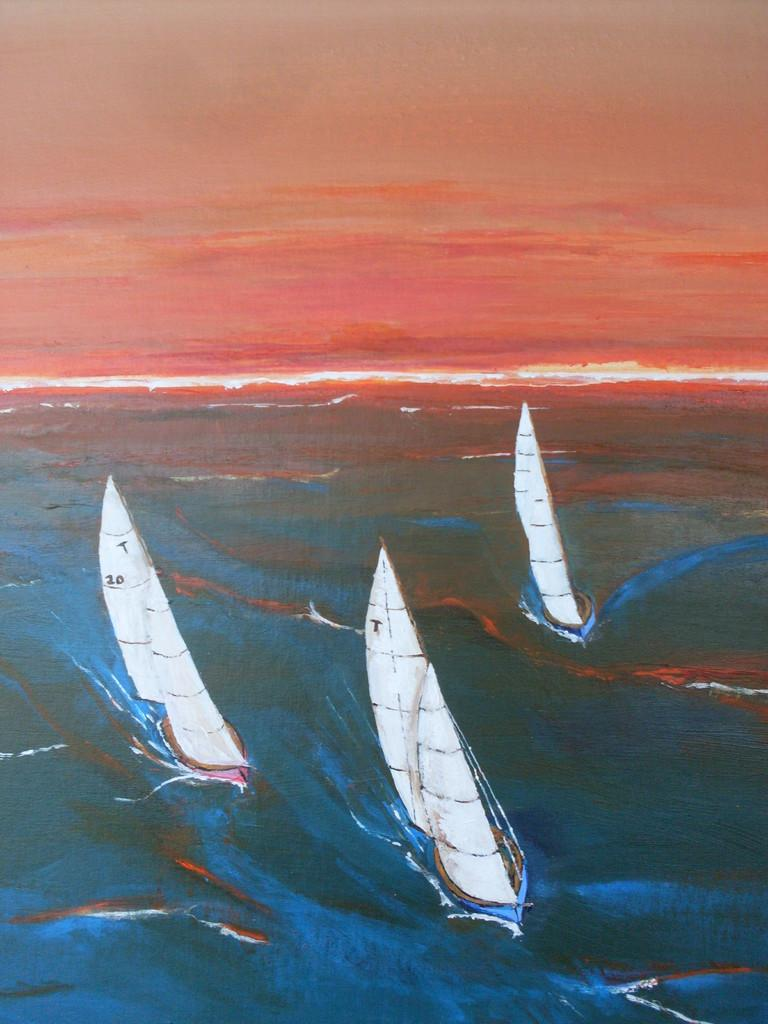<image>
Write a terse but informative summary of the picture. Three boats with one of them that has a sail with the letter T on it. 